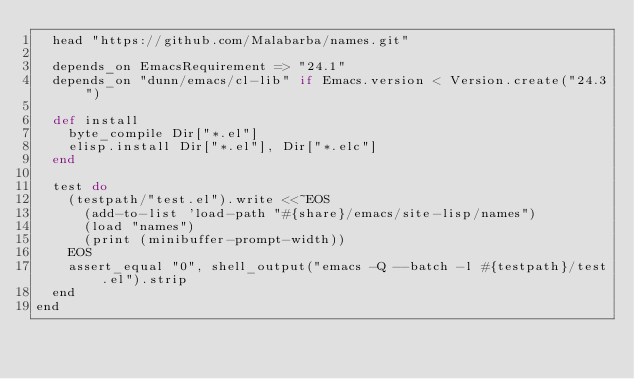<code> <loc_0><loc_0><loc_500><loc_500><_Ruby_>  head "https://github.com/Malabarba/names.git"

  depends_on EmacsRequirement => "24.1"
  depends_on "dunn/emacs/cl-lib" if Emacs.version < Version.create("24.3")

  def install
    byte_compile Dir["*.el"]
    elisp.install Dir["*.el"], Dir["*.elc"]
  end

  test do
    (testpath/"test.el").write <<~EOS
      (add-to-list 'load-path "#{share}/emacs/site-lisp/names")
      (load "names")
      (print (minibuffer-prompt-width))
    EOS
    assert_equal "0", shell_output("emacs -Q --batch -l #{testpath}/test.el").strip
  end
end
</code> 